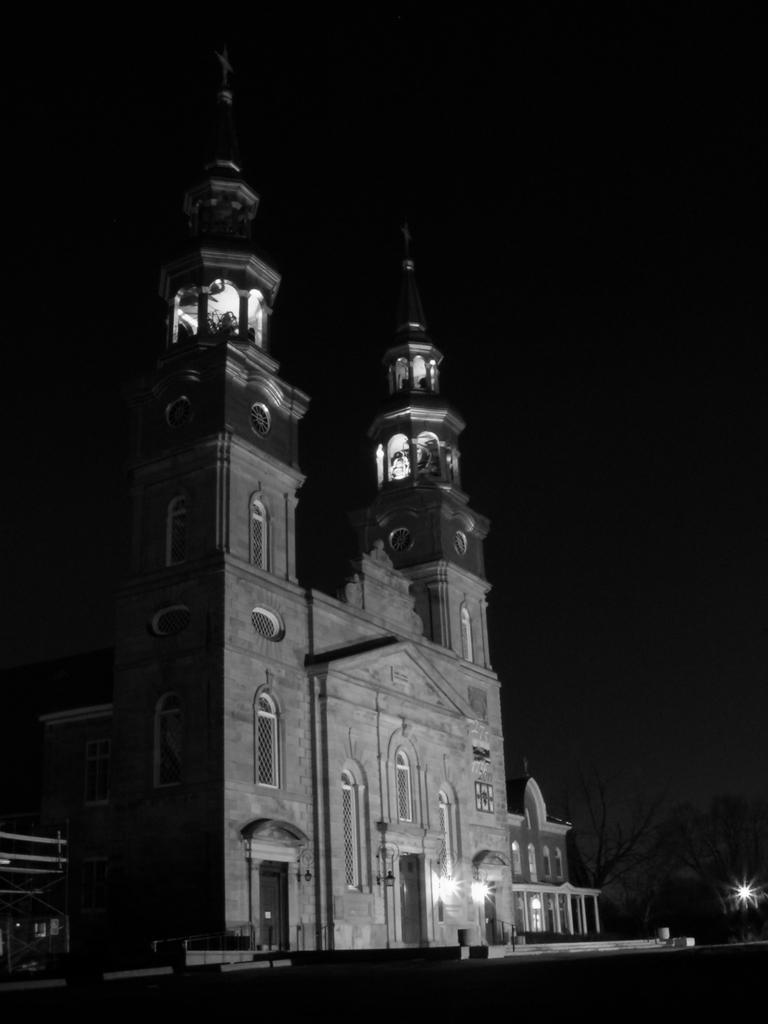What structure is located in the foreground of the image? There is a building in the foreground of the image. What can be seen in the image besides the building? Lights are visible in the image. What is visible at the top of the image? The sky is visible in the image. What time of day might the image have been taken? The image was likely taken during the night, as indicated by the presence of lights. How many tomatoes are visible on the roof of the building in the image? There are no tomatoes visible on the roof of the building in the image. What type of cup is being used by the grandfather in the image? There is no grandfather or cup present in the image. 